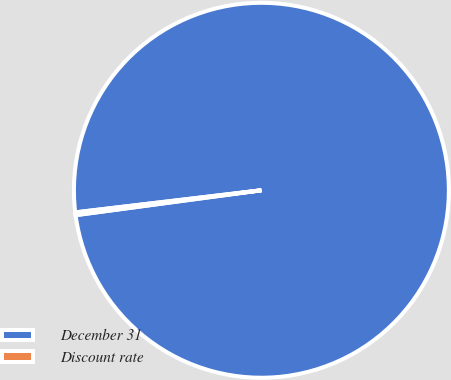<chart> <loc_0><loc_0><loc_500><loc_500><pie_chart><fcel>December 31<fcel>Discount rate<nl><fcel>99.76%<fcel>0.24%<nl></chart> 